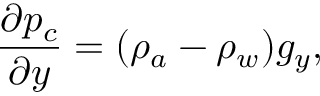<formula> <loc_0><loc_0><loc_500><loc_500>\frac { \partial p _ { c } } { \partial y } = ( \rho _ { a } - \rho _ { w } ) g _ { y } ,</formula> 